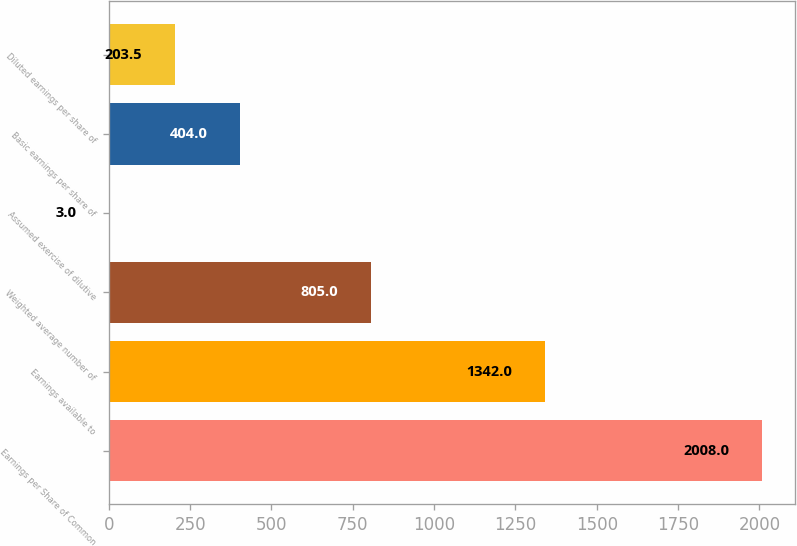Convert chart. <chart><loc_0><loc_0><loc_500><loc_500><bar_chart><fcel>Earnings per Share of Common<fcel>Earnings available to<fcel>Weighted average number of<fcel>Assumed exercise of dilutive<fcel>Basic earnings per share of<fcel>Diluted earnings per share of<nl><fcel>2008<fcel>1342<fcel>805<fcel>3<fcel>404<fcel>203.5<nl></chart> 